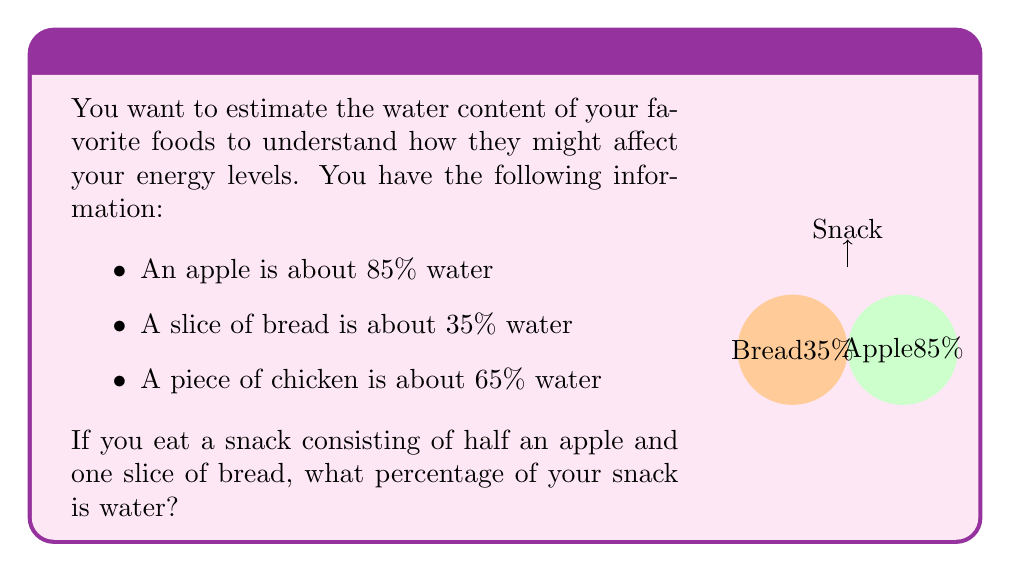Can you solve this math problem? Let's solve this step-by-step:

1) First, we need to consider the composition of the snack:
   - Half an apple
   - One slice of bread

2) Let's calculate the water content for each part:

   For half an apple:
   $$ \text{Water in half apple} = 85\% \times \frac{1}{2} = 42.5\% $$

   For one slice of bread:
   $$ \text{Water in bread} = 35\% $$

3) Now, we need to find the average of these two percentages. However, since we're dealing with half an apple and a whole slice of bread, we need to weight our average:

   $$ \text{Total water \%} = \frac{42.5 + 35}{2} = \frac{77.5}{2} = 38.75\% $$

4) Therefore, the water content of the entire snack is 38.75%.

This calculation assumes that half an apple and one slice of bread have roughly the same mass. If their masses were significantly different, we would need to account for that in our calculation.
Answer: 38.75% 